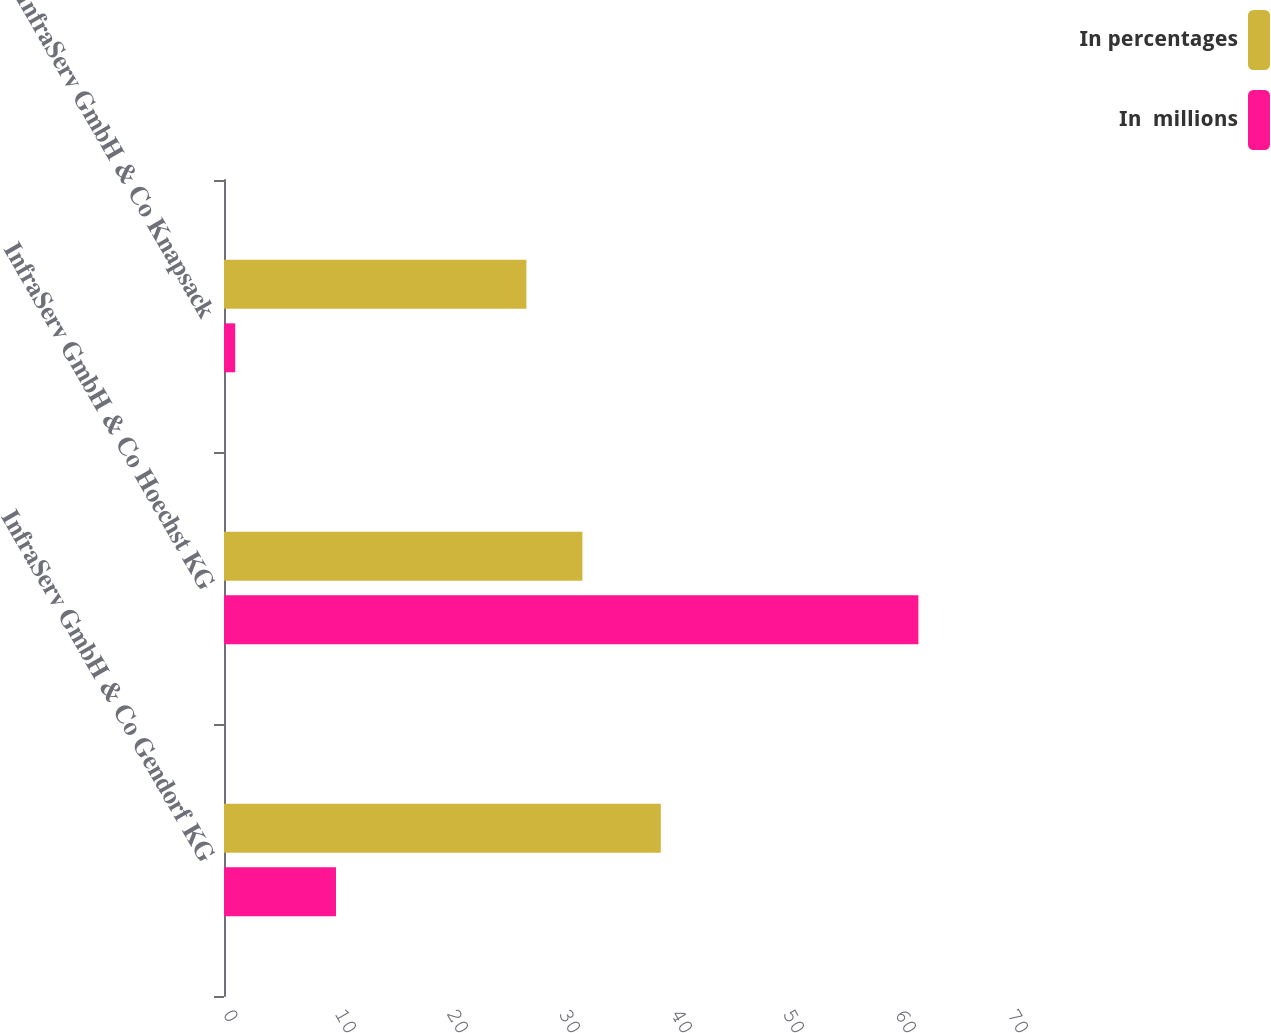Convert chart. <chart><loc_0><loc_0><loc_500><loc_500><stacked_bar_chart><ecel><fcel>InfraServ GmbH & Co Gendorf KG<fcel>InfraServ GmbH & Co Hoechst KG<fcel>InfraServ GmbH & Co Knapsack<nl><fcel>In percentages<fcel>39<fcel>32<fcel>27<nl><fcel>In  millions<fcel>10<fcel>62<fcel>1<nl></chart> 